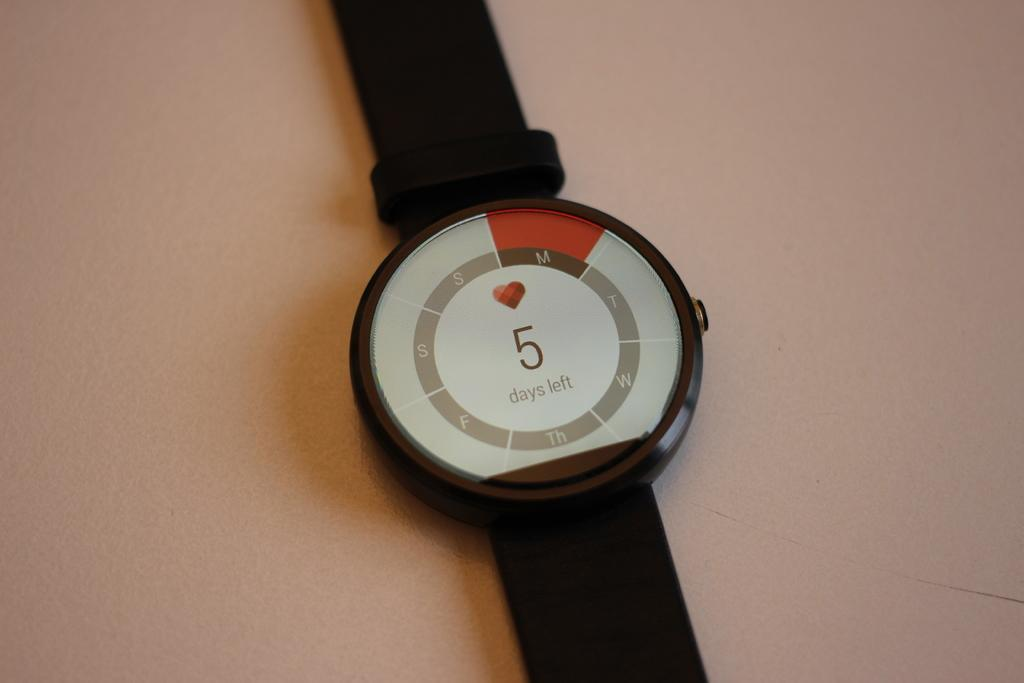<image>
Offer a succinct explanation of the picture presented. A watch that shows that there are currently 5 days left. 